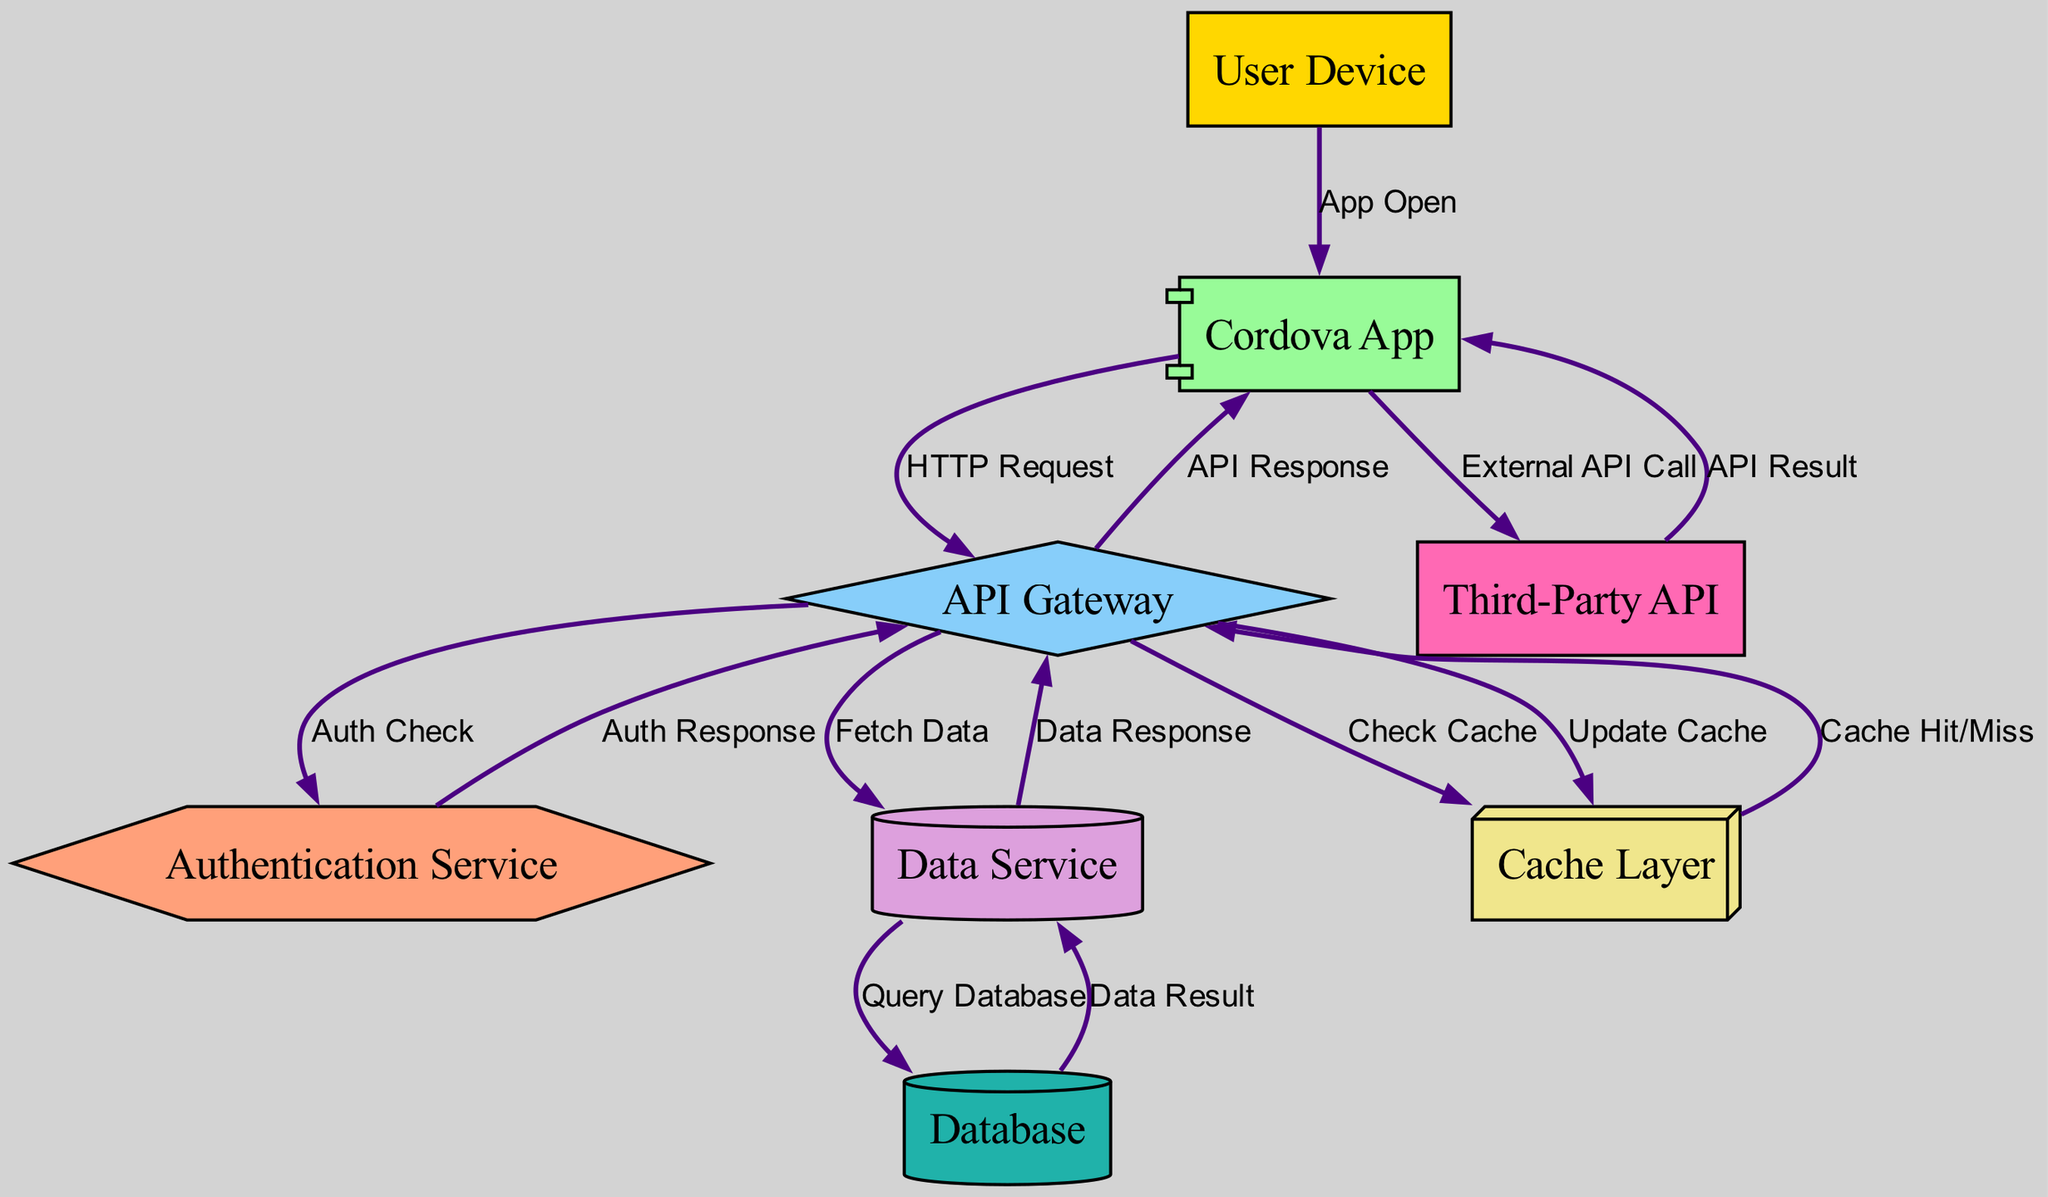What is the total number of nodes in the diagram? The diagram contains eight nodes, which are User Device, Cordova App, API Gateway, Authentication Service, Data Service, Cache Layer, Database, and Third-Party API.
Answer: Eight What is the label of the node that represents user interaction? The User Device is the node that represents user interaction in the diagram as it is the starting point of the data flow when the app is opened.
Answer: User Device Which node handles authentication checks? The Authentication Service node is responsible for conducting authentication checks as indicated by the edge labeled "Auth Check" connecting it to the API Gateway.
Answer: Authentication Service How many edges are there between the API Gateway and the Cordova App? There are two edges connecting the API Gateway to the Cordova App: one labeled "API Response" and another indirectly through the Data Service after data is fetched.
Answer: Two What happens if a cache hit occurs? In the case of a cache hit, the Cache Layer sends the "Cache Hit/Miss" response back to the API Gateway, which eliminates the need to fetch data from the Data Service.
Answer: Check Cache What is the response to a data fetch request? The data fetch request results in a "Data Response" being sent from the Data Service back to the API Gateway after querying the Database, which completes the data flow cycle for this operation.
Answer: Data Response What is the sequence of nodes when calling a Third-Party API? The sequence is Cordova App to Third-Party API, and then it returns the API Result back to the Cordova App, as indicated by the edges connecting these nodes.
Answer: Cordova App to Third-Party API What type of service is the Database represented as? The Database is represented as a cylinder, which is a common graphical representation for storage devices in data flow diagrams.
Answer: Cylinder 